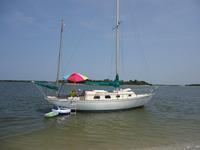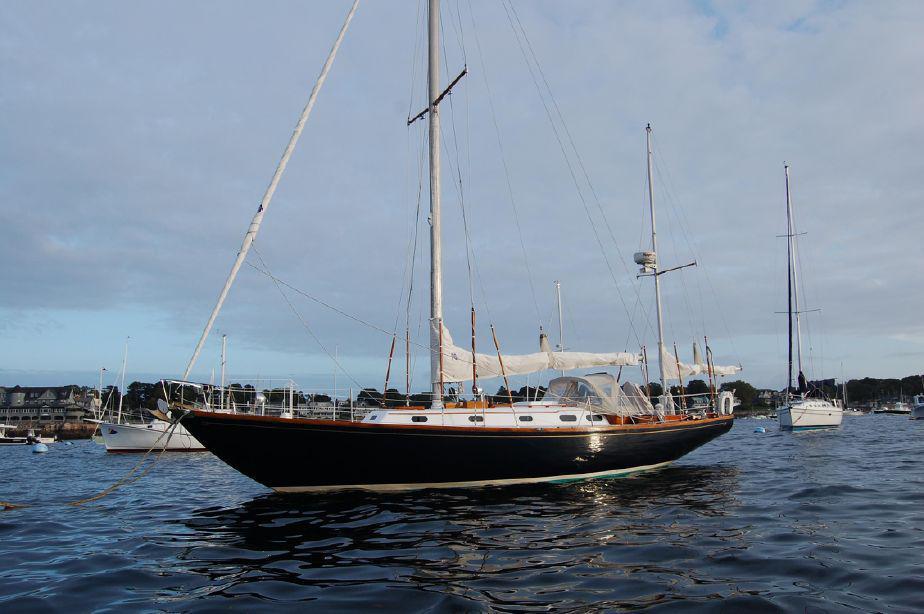The first image is the image on the left, the second image is the image on the right. Assess this claim about the two images: "A second boat is visible behind the closer boat in the image on the left.". Correct or not? Answer yes or no. No. The first image is the image on the left, the second image is the image on the right. Evaluate the accuracy of this statement regarding the images: "At least one white sail is up.". Is it true? Answer yes or no. No. 